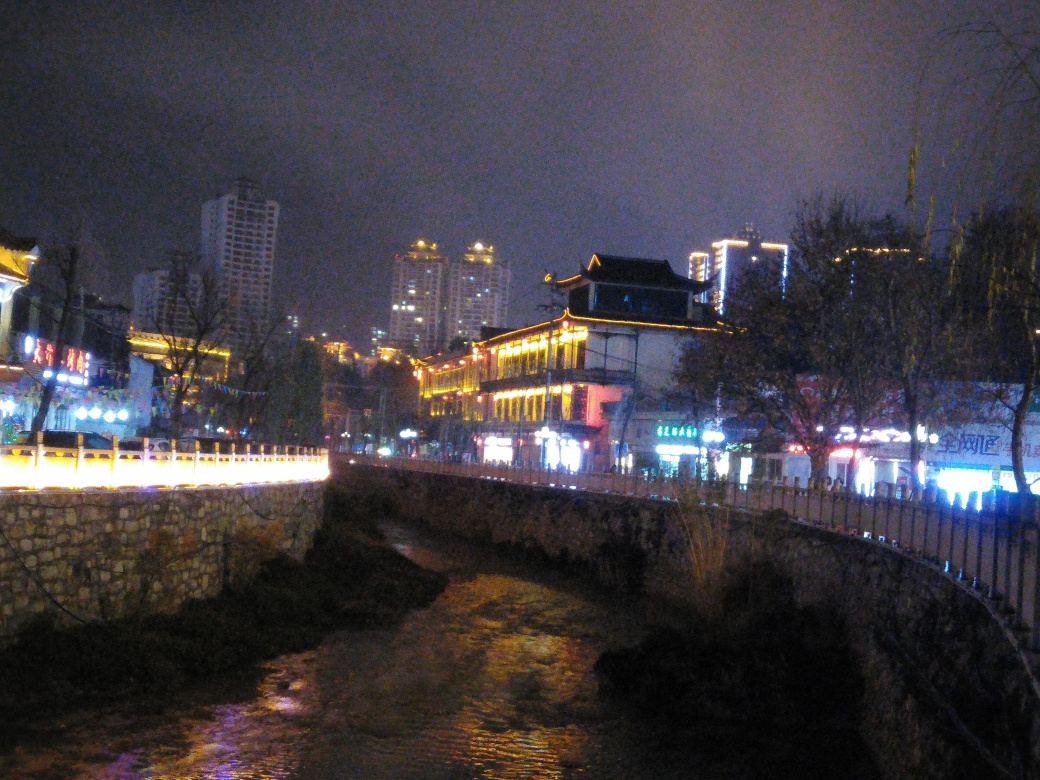How does the lighting affect the mood of the picture? The lighting significantly impacts the mood of the picture, creating a multi-faceted atmosphere. The warm and varied colors of the lights emit a sense of festivity and livelihood, particularly around the ancient building, which becomes a focal point bathed in a golden hue. Conversely, the cooler tones of the ambient night sky and water introduce a calm and somewhat mysterious quality. This interplay of warm and cool lighting weaves a visual narrative of tradition meeting modernity, with the traditional structure holding its own as a beacon amidst the urban night. 